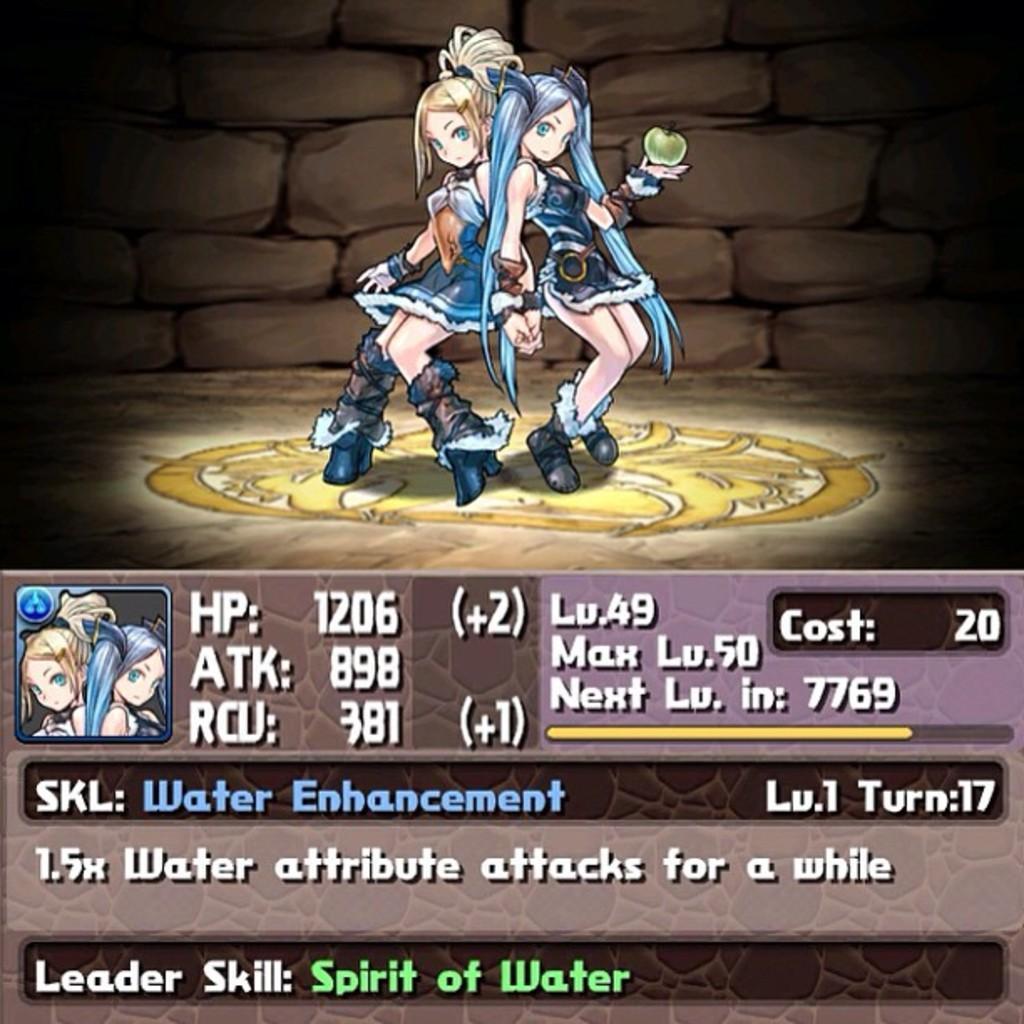Can you describe this image briefly? In this image there are two depicted personś,one person is holding an apple,there is a wall behind the person,there is text on the image. 